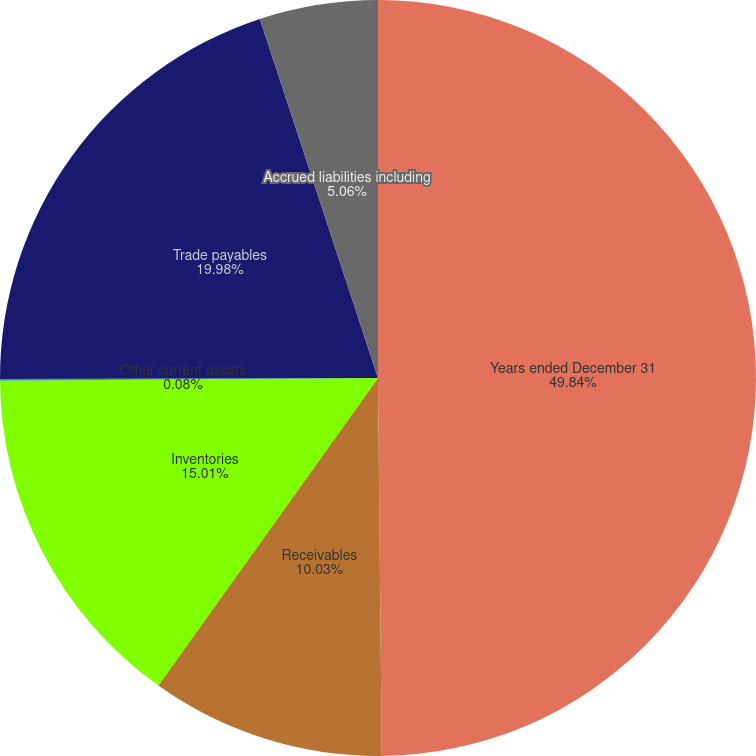Convert chart to OTSL. <chart><loc_0><loc_0><loc_500><loc_500><pie_chart><fcel>Years ended December 31<fcel>Receivables<fcel>Inventories<fcel>Other current assets<fcel>Trade payables<fcel>Accrued liabilities including<nl><fcel>49.84%<fcel>10.03%<fcel>15.01%<fcel>0.08%<fcel>19.98%<fcel>5.06%<nl></chart> 